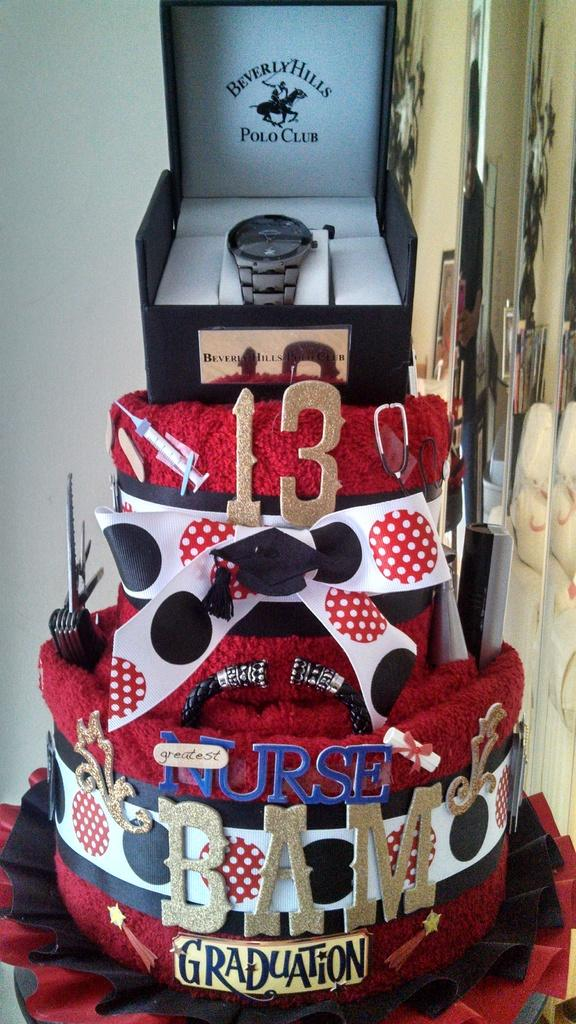Provide a one-sentence caption for the provided image. Polo Club watch on top of a red cake. 